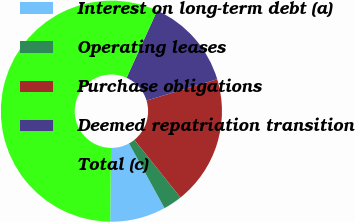Convert chart to OTSL. <chart><loc_0><loc_0><loc_500><loc_500><pie_chart><fcel>Interest on long-term debt (a)<fcel>Operating leases<fcel>Purchase obligations<fcel>Deemed repatriation transition<fcel>Total (c)<nl><fcel>8.15%<fcel>2.77%<fcel>18.92%<fcel>13.54%<fcel>56.62%<nl></chart> 